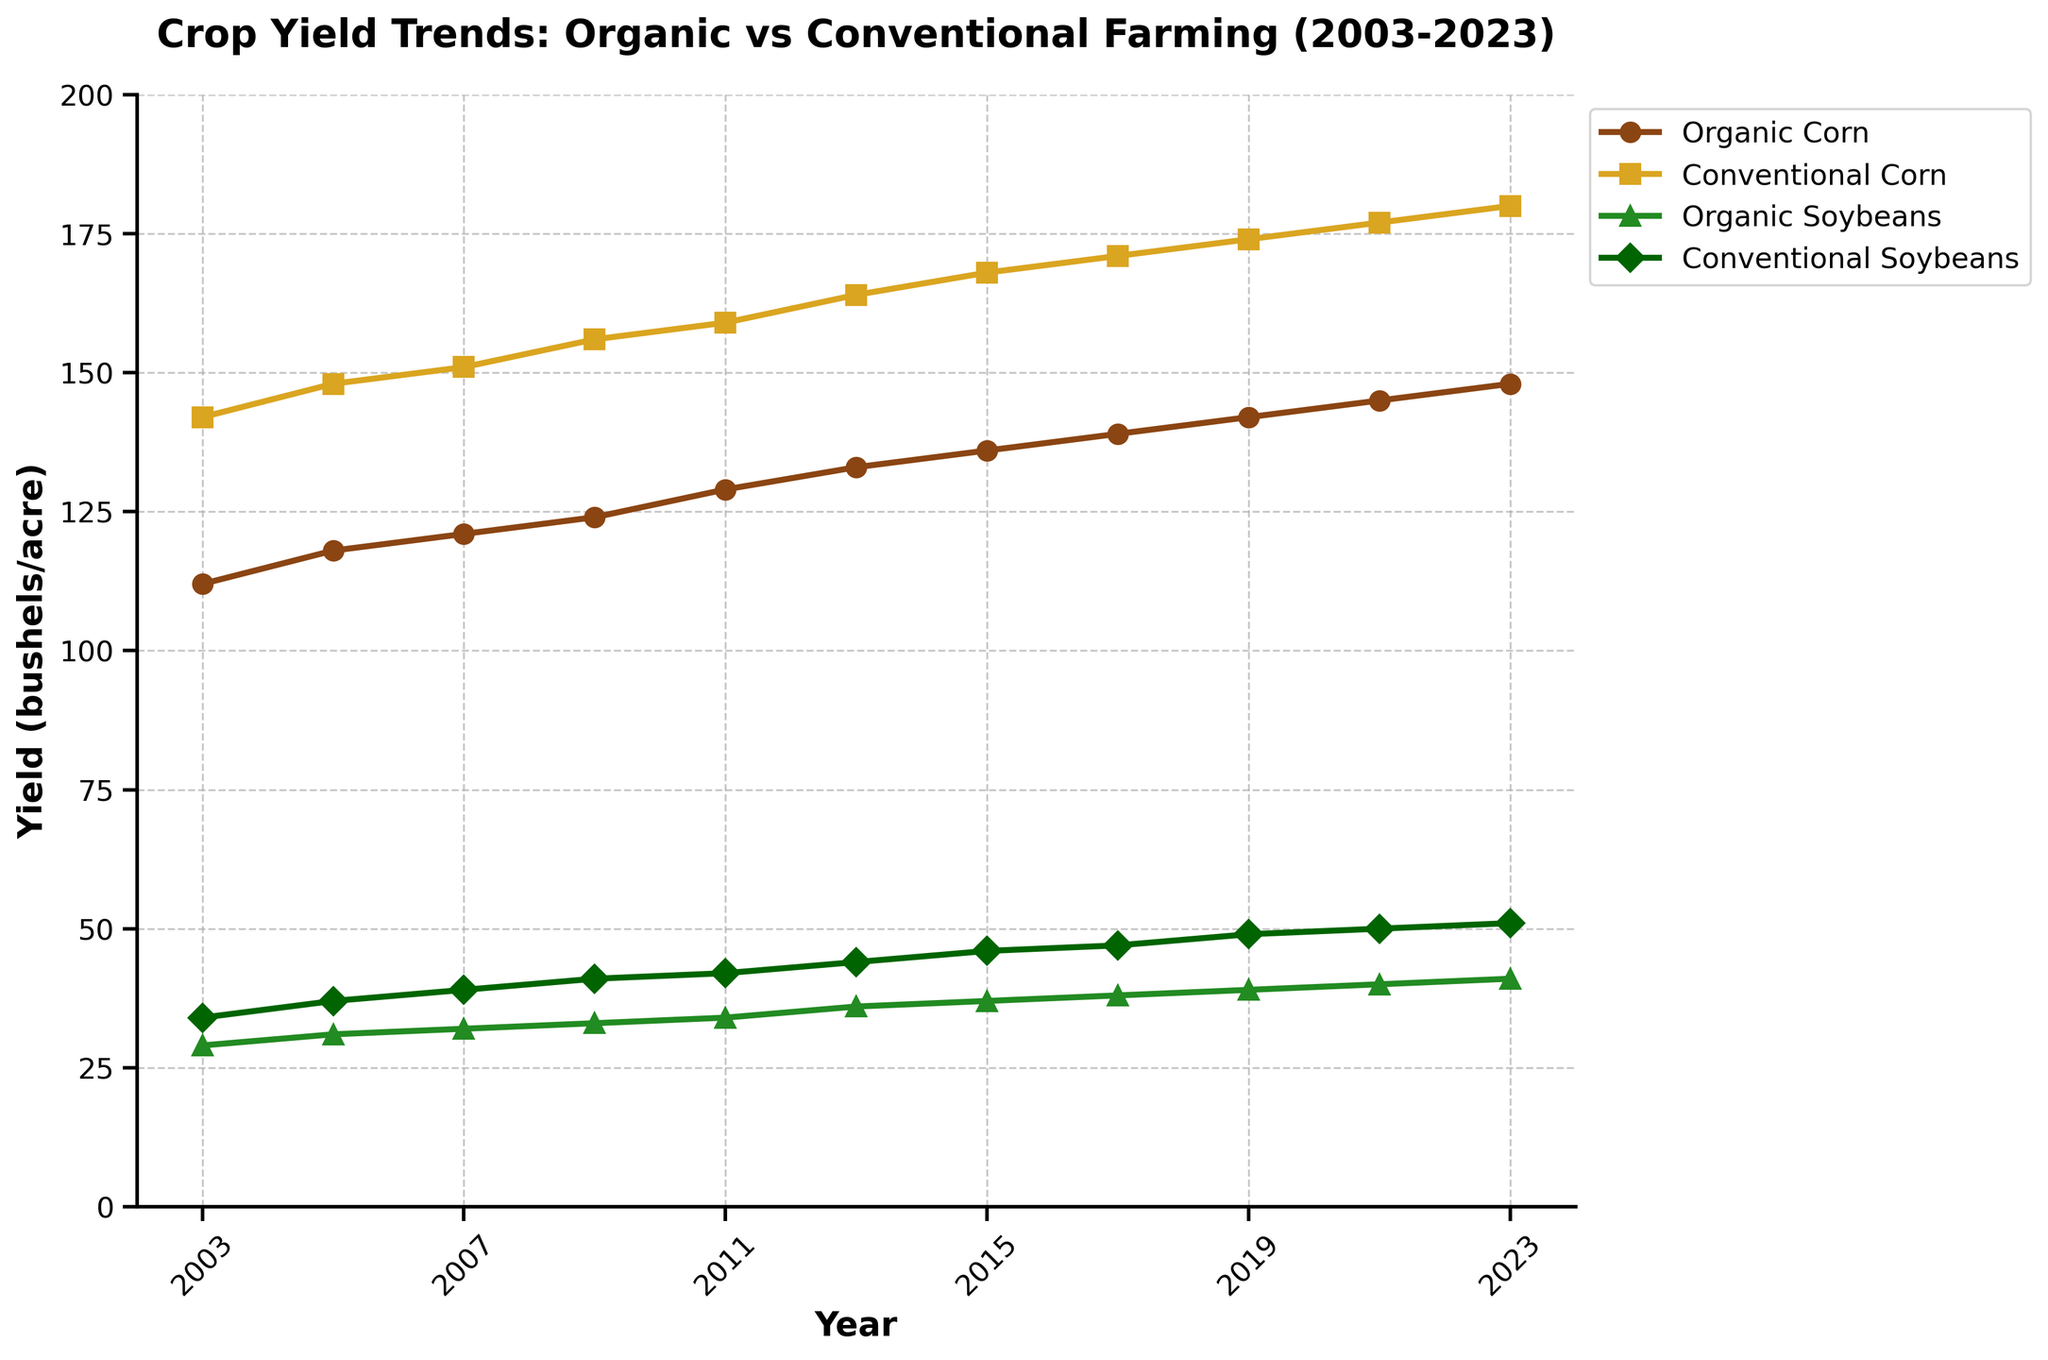What is the difference in yield between Organic Corn and Conventional Corn in 2023? In 2023, Organic Corn yield is 148 bushels/acre, and Conventional Corn yield is 180 bushels/acre. Subtract the Organic Corn yield from the Conventional Corn yield: 180 - 148 = 32
Answer: 32 Which type of farming showed a greater increase in corn yield from 2003 to 2023? The yield for Organic Corn in 2003 is 112 bushels/acre and in 2023 is 148 bushels/acre. The yield for Conventional Corn in 2003 is 142 bushels/acre and in 2023 is 180 bushels/acre. The increase for Organic Corn is 148 - 112 = 36 bushels/acre, and for Conventional Corn, the increase is 180 - 142 = 38 bushels/acre. Therefore, Conventional Corn showed a greater increase.
Answer: Conventional Corn What is the average yield of Organic Soybeans from 2019 to 2023? The yields for Organic Soybeans from 2019 to 2023 are: 39, 40, 41 bushels/acre. Add these values: 39 + 40 + 41 = 120, and divide by the number of years (3): 120 / 3 = 40
Answer: 40 In which year did Conventional Corn yield exceed 160 bushels/acre for the first time? By looking at the data points for Conventional Corn, we see that the yield in 2013 is 164 bushels/acre, which is the first time it exceeds 160.
Answer: 2013 By how much did the yield of Organic Soybeans increase between 2003 and 2023? In 2003, the yield for Organic Soybeans is 29 bushels/acre, and in 2023 it is 41 bushels/acre. The increase is 41 - 29 = 12 bushels/acre.
Answer: 12 What is the yield range for Conventional Soybeans over the 20-year period? The lowest yield for Conventional Soybeans in the data is in 2003 at 34 bushels/acre, and the highest is in 2023 at 51 bushels/acre. The range is 51 - 34 = 17 bushels/acre.
Answer: 17 What color represents Organic Soybeans in the chart? By referring to the visual attributes of the chart, Organic Soybeans are represented by the green line (color associated with '#228B22').
Answer: Green 